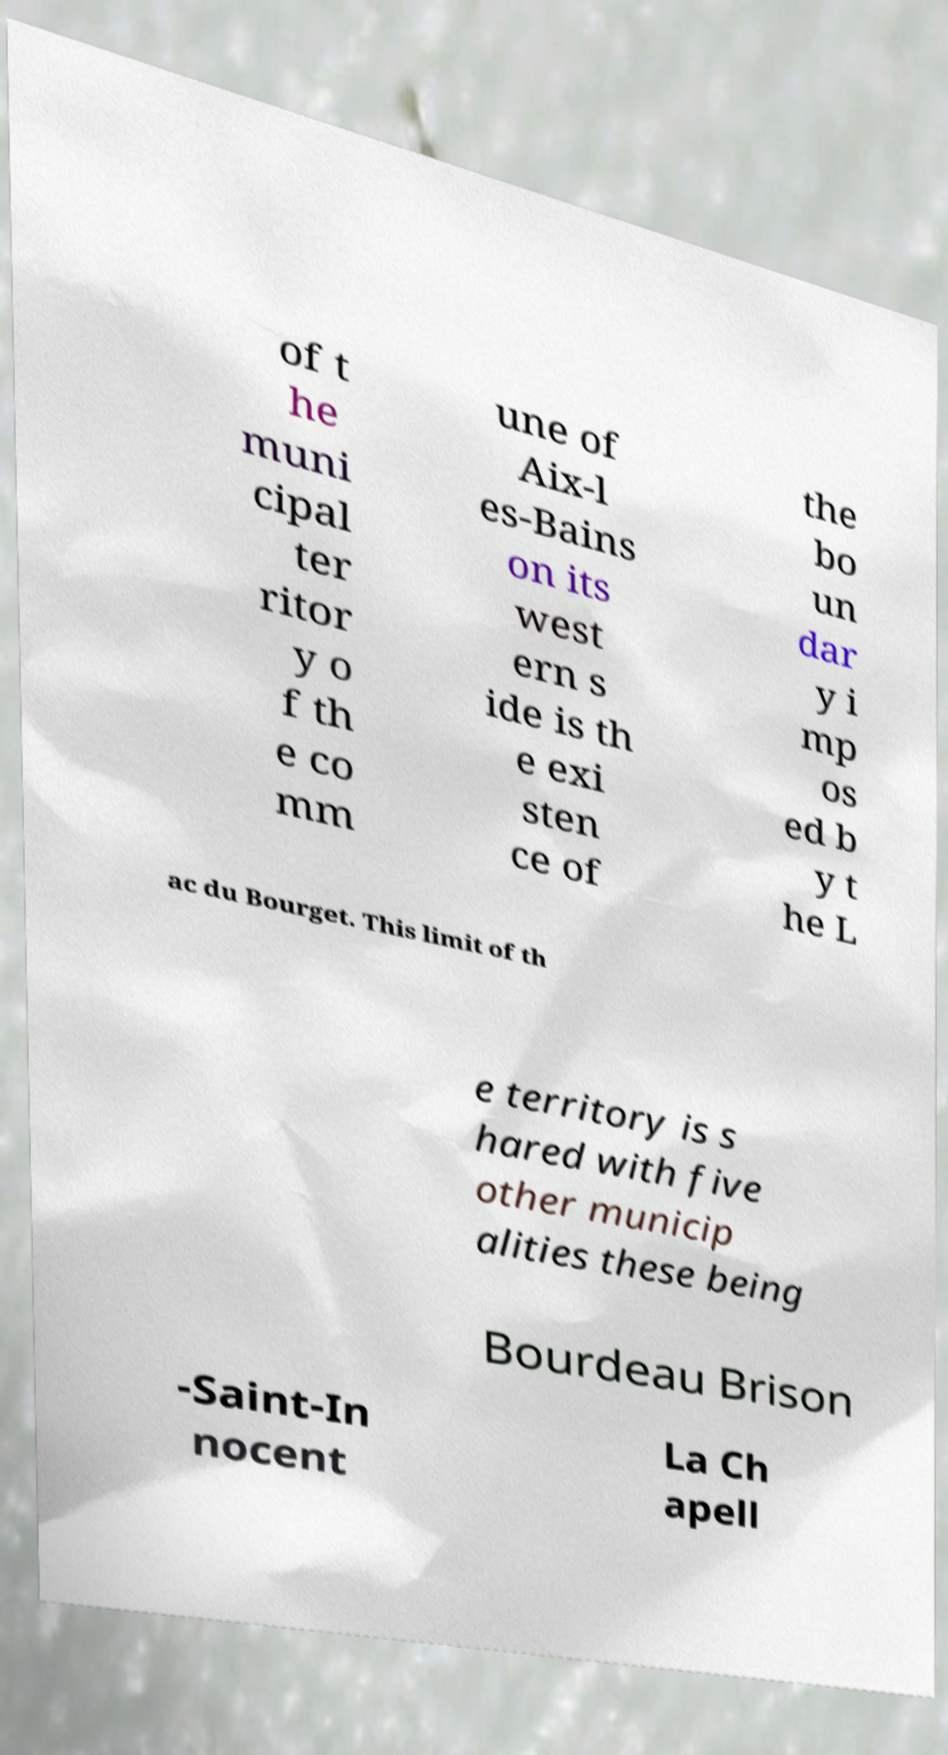Please identify and transcribe the text found in this image. of t he muni cipal ter ritor y o f th e co mm une of Aix-l es-Bains on its west ern s ide is th e exi sten ce of the bo un dar y i mp os ed b y t he L ac du Bourget. This limit of th e territory is s hared with five other municip alities these being Bourdeau Brison -Saint-In nocent La Ch apell 